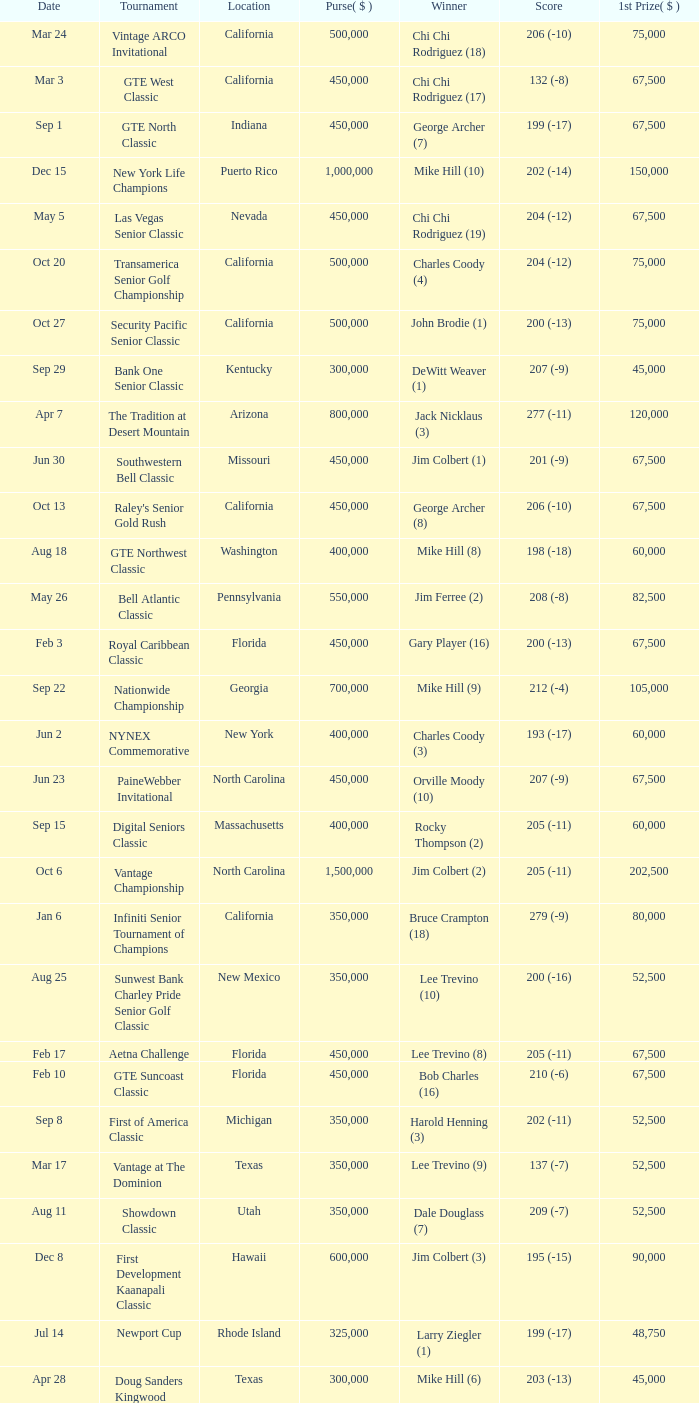Where was the security pacific senior classic? California. 